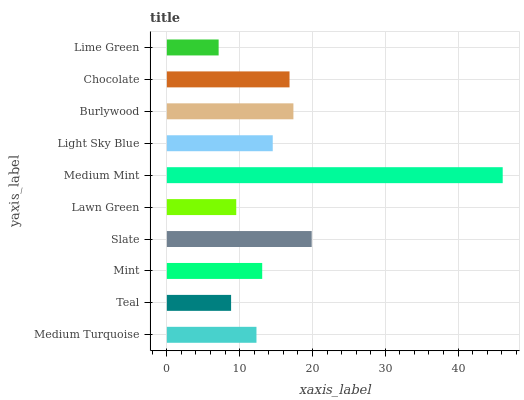Is Lime Green the minimum?
Answer yes or no. Yes. Is Medium Mint the maximum?
Answer yes or no. Yes. Is Teal the minimum?
Answer yes or no. No. Is Teal the maximum?
Answer yes or no. No. Is Medium Turquoise greater than Teal?
Answer yes or no. Yes. Is Teal less than Medium Turquoise?
Answer yes or no. Yes. Is Teal greater than Medium Turquoise?
Answer yes or no. No. Is Medium Turquoise less than Teal?
Answer yes or no. No. Is Light Sky Blue the high median?
Answer yes or no. Yes. Is Mint the low median?
Answer yes or no. Yes. Is Medium Mint the high median?
Answer yes or no. No. Is Chocolate the low median?
Answer yes or no. No. 